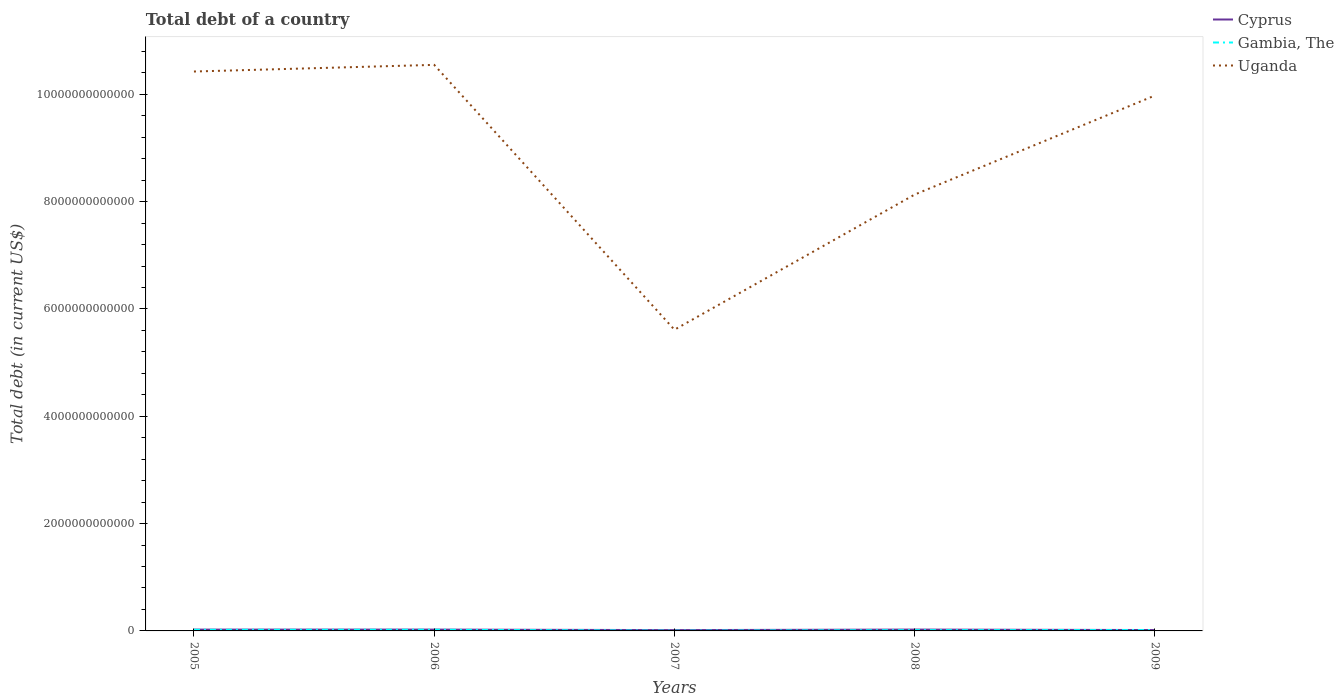Does the line corresponding to Cyprus intersect with the line corresponding to Uganda?
Provide a short and direct response. No. Is the number of lines equal to the number of legend labels?
Offer a very short reply. Yes. Across all years, what is the maximum debt in Gambia, The?
Provide a short and direct response. 4.74e+09. What is the total debt in Gambia, The in the graph?
Offer a very short reply. -1.09e+1. What is the difference between the highest and the second highest debt in Gambia, The?
Offer a very short reply. 1.70e+1. What is the difference between the highest and the lowest debt in Cyprus?
Make the answer very short. 3. What is the difference between two consecutive major ticks on the Y-axis?
Offer a terse response. 2.00e+12. Are the values on the major ticks of Y-axis written in scientific E-notation?
Give a very brief answer. No. Does the graph contain any zero values?
Provide a succinct answer. No. Does the graph contain grids?
Your answer should be compact. No. Where does the legend appear in the graph?
Your answer should be very brief. Top right. How are the legend labels stacked?
Your answer should be very brief. Vertical. What is the title of the graph?
Provide a short and direct response. Total debt of a country. What is the label or title of the X-axis?
Offer a terse response. Years. What is the label or title of the Y-axis?
Your answer should be very brief. Total debt (in current US$). What is the Total debt (in current US$) of Cyprus in 2005?
Your response must be concise. 2.43e+1. What is the Total debt (in current US$) in Gambia, The in 2005?
Provide a succinct answer. 2.06e+1. What is the Total debt (in current US$) in Uganda in 2005?
Your response must be concise. 1.04e+13. What is the Total debt (in current US$) in Cyprus in 2006?
Your answer should be very brief. 2.47e+1. What is the Total debt (in current US$) in Gambia, The in 2006?
Give a very brief answer. 2.18e+1. What is the Total debt (in current US$) in Uganda in 2006?
Make the answer very short. 1.05e+13. What is the Total debt (in current US$) in Cyprus in 2007?
Ensure brevity in your answer.  1.54e+1. What is the Total debt (in current US$) in Gambia, The in 2007?
Provide a short and direct response. 4.74e+09. What is the Total debt (in current US$) in Uganda in 2007?
Your answer should be compact. 5.61e+12. What is the Total debt (in current US$) of Cyprus in 2008?
Make the answer very short. 2.49e+1. What is the Total debt (in current US$) of Gambia, The in 2008?
Ensure brevity in your answer.  1.49e+1. What is the Total debt (in current US$) in Uganda in 2008?
Your answer should be compact. 8.13e+12. What is the Total debt (in current US$) of Cyprus in 2009?
Offer a very short reply. 1.65e+1. What is the Total debt (in current US$) of Gambia, The in 2009?
Make the answer very short. 1.56e+1. What is the Total debt (in current US$) in Uganda in 2009?
Your response must be concise. 9.98e+12. Across all years, what is the maximum Total debt (in current US$) of Cyprus?
Offer a very short reply. 2.49e+1. Across all years, what is the maximum Total debt (in current US$) in Gambia, The?
Your answer should be very brief. 2.18e+1. Across all years, what is the maximum Total debt (in current US$) in Uganda?
Provide a short and direct response. 1.05e+13. Across all years, what is the minimum Total debt (in current US$) of Cyprus?
Provide a short and direct response. 1.54e+1. Across all years, what is the minimum Total debt (in current US$) in Gambia, The?
Offer a terse response. 4.74e+09. Across all years, what is the minimum Total debt (in current US$) of Uganda?
Provide a short and direct response. 5.61e+12. What is the total Total debt (in current US$) of Cyprus in the graph?
Your answer should be very brief. 1.06e+11. What is the total Total debt (in current US$) in Gambia, The in the graph?
Offer a very short reply. 7.76e+1. What is the total Total debt (in current US$) in Uganda in the graph?
Your answer should be compact. 4.47e+13. What is the difference between the Total debt (in current US$) in Cyprus in 2005 and that in 2006?
Your response must be concise. -4.30e+08. What is the difference between the Total debt (in current US$) in Gambia, The in 2005 and that in 2006?
Provide a succinct answer. -1.20e+09. What is the difference between the Total debt (in current US$) in Uganda in 2005 and that in 2006?
Keep it short and to the point. -1.24e+11. What is the difference between the Total debt (in current US$) of Cyprus in 2005 and that in 2007?
Make the answer very short. 8.95e+09. What is the difference between the Total debt (in current US$) of Gambia, The in 2005 and that in 2007?
Provide a short and direct response. 1.58e+1. What is the difference between the Total debt (in current US$) of Uganda in 2005 and that in 2007?
Your answer should be compact. 4.81e+12. What is the difference between the Total debt (in current US$) of Cyprus in 2005 and that in 2008?
Keep it short and to the point. -6.18e+08. What is the difference between the Total debt (in current US$) in Gambia, The in 2005 and that in 2008?
Offer a very short reply. 5.69e+09. What is the difference between the Total debt (in current US$) in Uganda in 2005 and that in 2008?
Your response must be concise. 2.29e+12. What is the difference between the Total debt (in current US$) of Cyprus in 2005 and that in 2009?
Provide a short and direct response. 7.77e+09. What is the difference between the Total debt (in current US$) in Gambia, The in 2005 and that in 2009?
Your answer should be compact. 4.96e+09. What is the difference between the Total debt (in current US$) in Uganda in 2005 and that in 2009?
Provide a short and direct response. 4.47e+11. What is the difference between the Total debt (in current US$) of Cyprus in 2006 and that in 2007?
Give a very brief answer. 9.38e+09. What is the difference between the Total debt (in current US$) in Gambia, The in 2006 and that in 2007?
Your response must be concise. 1.70e+1. What is the difference between the Total debt (in current US$) in Uganda in 2006 and that in 2007?
Make the answer very short. 4.94e+12. What is the difference between the Total debt (in current US$) in Cyprus in 2006 and that in 2008?
Your answer should be very brief. -1.88e+08. What is the difference between the Total debt (in current US$) in Gambia, The in 2006 and that in 2008?
Make the answer very short. 6.89e+09. What is the difference between the Total debt (in current US$) of Uganda in 2006 and that in 2008?
Your answer should be very brief. 2.42e+12. What is the difference between the Total debt (in current US$) in Cyprus in 2006 and that in 2009?
Offer a very short reply. 8.20e+09. What is the difference between the Total debt (in current US$) of Gambia, The in 2006 and that in 2009?
Provide a short and direct response. 6.16e+09. What is the difference between the Total debt (in current US$) of Uganda in 2006 and that in 2009?
Your response must be concise. 5.71e+11. What is the difference between the Total debt (in current US$) of Cyprus in 2007 and that in 2008?
Keep it short and to the point. -9.57e+09. What is the difference between the Total debt (in current US$) in Gambia, The in 2007 and that in 2008?
Offer a terse response. -1.01e+1. What is the difference between the Total debt (in current US$) of Uganda in 2007 and that in 2008?
Your response must be concise. -2.52e+12. What is the difference between the Total debt (in current US$) of Cyprus in 2007 and that in 2009?
Provide a short and direct response. -1.17e+09. What is the difference between the Total debt (in current US$) of Gambia, The in 2007 and that in 2009?
Keep it short and to the point. -1.09e+1. What is the difference between the Total debt (in current US$) of Uganda in 2007 and that in 2009?
Offer a very short reply. -4.36e+12. What is the difference between the Total debt (in current US$) in Cyprus in 2008 and that in 2009?
Make the answer very short. 8.39e+09. What is the difference between the Total debt (in current US$) of Gambia, The in 2008 and that in 2009?
Give a very brief answer. -7.27e+08. What is the difference between the Total debt (in current US$) in Uganda in 2008 and that in 2009?
Your answer should be compact. -1.85e+12. What is the difference between the Total debt (in current US$) of Cyprus in 2005 and the Total debt (in current US$) of Gambia, The in 2006?
Ensure brevity in your answer.  2.54e+09. What is the difference between the Total debt (in current US$) of Cyprus in 2005 and the Total debt (in current US$) of Uganda in 2006?
Ensure brevity in your answer.  -1.05e+13. What is the difference between the Total debt (in current US$) of Gambia, The in 2005 and the Total debt (in current US$) of Uganda in 2006?
Ensure brevity in your answer.  -1.05e+13. What is the difference between the Total debt (in current US$) of Cyprus in 2005 and the Total debt (in current US$) of Gambia, The in 2007?
Offer a terse response. 1.96e+1. What is the difference between the Total debt (in current US$) of Cyprus in 2005 and the Total debt (in current US$) of Uganda in 2007?
Make the answer very short. -5.59e+12. What is the difference between the Total debt (in current US$) of Gambia, The in 2005 and the Total debt (in current US$) of Uganda in 2007?
Your response must be concise. -5.59e+12. What is the difference between the Total debt (in current US$) in Cyprus in 2005 and the Total debt (in current US$) in Gambia, The in 2008?
Make the answer very short. 9.42e+09. What is the difference between the Total debt (in current US$) in Cyprus in 2005 and the Total debt (in current US$) in Uganda in 2008?
Make the answer very short. -8.11e+12. What is the difference between the Total debt (in current US$) in Gambia, The in 2005 and the Total debt (in current US$) in Uganda in 2008?
Provide a short and direct response. -8.11e+12. What is the difference between the Total debt (in current US$) in Cyprus in 2005 and the Total debt (in current US$) in Gambia, The in 2009?
Make the answer very short. 8.70e+09. What is the difference between the Total debt (in current US$) of Cyprus in 2005 and the Total debt (in current US$) of Uganda in 2009?
Keep it short and to the point. -9.95e+12. What is the difference between the Total debt (in current US$) in Gambia, The in 2005 and the Total debt (in current US$) in Uganda in 2009?
Make the answer very short. -9.96e+12. What is the difference between the Total debt (in current US$) of Cyprus in 2006 and the Total debt (in current US$) of Gambia, The in 2007?
Offer a terse response. 2.00e+1. What is the difference between the Total debt (in current US$) of Cyprus in 2006 and the Total debt (in current US$) of Uganda in 2007?
Offer a terse response. -5.59e+12. What is the difference between the Total debt (in current US$) in Gambia, The in 2006 and the Total debt (in current US$) in Uganda in 2007?
Give a very brief answer. -5.59e+12. What is the difference between the Total debt (in current US$) in Cyprus in 2006 and the Total debt (in current US$) in Gambia, The in 2008?
Offer a very short reply. 9.85e+09. What is the difference between the Total debt (in current US$) of Cyprus in 2006 and the Total debt (in current US$) of Uganda in 2008?
Your answer should be very brief. -8.11e+12. What is the difference between the Total debt (in current US$) of Gambia, The in 2006 and the Total debt (in current US$) of Uganda in 2008?
Your response must be concise. -8.11e+12. What is the difference between the Total debt (in current US$) of Cyprus in 2006 and the Total debt (in current US$) of Gambia, The in 2009?
Offer a very short reply. 9.13e+09. What is the difference between the Total debt (in current US$) in Cyprus in 2006 and the Total debt (in current US$) in Uganda in 2009?
Your response must be concise. -9.95e+12. What is the difference between the Total debt (in current US$) of Gambia, The in 2006 and the Total debt (in current US$) of Uganda in 2009?
Provide a succinct answer. -9.96e+12. What is the difference between the Total debt (in current US$) of Cyprus in 2007 and the Total debt (in current US$) of Gambia, The in 2008?
Provide a short and direct response. 4.76e+08. What is the difference between the Total debt (in current US$) of Cyprus in 2007 and the Total debt (in current US$) of Uganda in 2008?
Give a very brief answer. -8.12e+12. What is the difference between the Total debt (in current US$) of Gambia, The in 2007 and the Total debt (in current US$) of Uganda in 2008?
Offer a very short reply. -8.13e+12. What is the difference between the Total debt (in current US$) in Cyprus in 2007 and the Total debt (in current US$) in Gambia, The in 2009?
Offer a very short reply. -2.51e+08. What is the difference between the Total debt (in current US$) in Cyprus in 2007 and the Total debt (in current US$) in Uganda in 2009?
Your answer should be very brief. -9.96e+12. What is the difference between the Total debt (in current US$) of Gambia, The in 2007 and the Total debt (in current US$) of Uganda in 2009?
Provide a short and direct response. -9.97e+12. What is the difference between the Total debt (in current US$) in Cyprus in 2008 and the Total debt (in current US$) in Gambia, The in 2009?
Your answer should be very brief. 9.32e+09. What is the difference between the Total debt (in current US$) in Cyprus in 2008 and the Total debt (in current US$) in Uganda in 2009?
Provide a short and direct response. -9.95e+12. What is the difference between the Total debt (in current US$) in Gambia, The in 2008 and the Total debt (in current US$) in Uganda in 2009?
Offer a terse response. -9.96e+12. What is the average Total debt (in current US$) in Cyprus per year?
Give a very brief answer. 2.12e+1. What is the average Total debt (in current US$) of Gambia, The per year?
Provide a short and direct response. 1.55e+1. What is the average Total debt (in current US$) of Uganda per year?
Offer a terse response. 8.94e+12. In the year 2005, what is the difference between the Total debt (in current US$) of Cyprus and Total debt (in current US$) of Gambia, The?
Your answer should be compact. 3.74e+09. In the year 2005, what is the difference between the Total debt (in current US$) of Cyprus and Total debt (in current US$) of Uganda?
Give a very brief answer. -1.04e+13. In the year 2005, what is the difference between the Total debt (in current US$) in Gambia, The and Total debt (in current US$) in Uganda?
Your response must be concise. -1.04e+13. In the year 2006, what is the difference between the Total debt (in current US$) of Cyprus and Total debt (in current US$) of Gambia, The?
Provide a succinct answer. 2.97e+09. In the year 2006, what is the difference between the Total debt (in current US$) of Cyprus and Total debt (in current US$) of Uganda?
Keep it short and to the point. -1.05e+13. In the year 2006, what is the difference between the Total debt (in current US$) in Gambia, The and Total debt (in current US$) in Uganda?
Provide a succinct answer. -1.05e+13. In the year 2007, what is the difference between the Total debt (in current US$) of Cyprus and Total debt (in current US$) of Gambia, The?
Your answer should be very brief. 1.06e+1. In the year 2007, what is the difference between the Total debt (in current US$) in Cyprus and Total debt (in current US$) in Uganda?
Ensure brevity in your answer.  -5.60e+12. In the year 2007, what is the difference between the Total debt (in current US$) of Gambia, The and Total debt (in current US$) of Uganda?
Provide a succinct answer. -5.61e+12. In the year 2008, what is the difference between the Total debt (in current US$) of Cyprus and Total debt (in current US$) of Gambia, The?
Offer a very short reply. 1.00e+1. In the year 2008, what is the difference between the Total debt (in current US$) of Cyprus and Total debt (in current US$) of Uganda?
Your answer should be compact. -8.11e+12. In the year 2008, what is the difference between the Total debt (in current US$) of Gambia, The and Total debt (in current US$) of Uganda?
Your answer should be very brief. -8.12e+12. In the year 2009, what is the difference between the Total debt (in current US$) of Cyprus and Total debt (in current US$) of Gambia, The?
Your response must be concise. 9.22e+08. In the year 2009, what is the difference between the Total debt (in current US$) in Cyprus and Total debt (in current US$) in Uganda?
Your response must be concise. -9.96e+12. In the year 2009, what is the difference between the Total debt (in current US$) in Gambia, The and Total debt (in current US$) in Uganda?
Your response must be concise. -9.96e+12. What is the ratio of the Total debt (in current US$) in Cyprus in 2005 to that in 2006?
Keep it short and to the point. 0.98. What is the ratio of the Total debt (in current US$) of Gambia, The in 2005 to that in 2006?
Your answer should be very brief. 0.94. What is the ratio of the Total debt (in current US$) of Uganda in 2005 to that in 2006?
Ensure brevity in your answer.  0.99. What is the ratio of the Total debt (in current US$) of Cyprus in 2005 to that in 2007?
Your answer should be compact. 1.58. What is the ratio of the Total debt (in current US$) of Gambia, The in 2005 to that in 2007?
Offer a very short reply. 4.34. What is the ratio of the Total debt (in current US$) of Uganda in 2005 to that in 2007?
Make the answer very short. 1.86. What is the ratio of the Total debt (in current US$) of Cyprus in 2005 to that in 2008?
Ensure brevity in your answer.  0.98. What is the ratio of the Total debt (in current US$) of Gambia, The in 2005 to that in 2008?
Provide a succinct answer. 1.38. What is the ratio of the Total debt (in current US$) in Uganda in 2005 to that in 2008?
Make the answer very short. 1.28. What is the ratio of the Total debt (in current US$) of Cyprus in 2005 to that in 2009?
Your response must be concise. 1.47. What is the ratio of the Total debt (in current US$) in Gambia, The in 2005 to that in 2009?
Your answer should be very brief. 1.32. What is the ratio of the Total debt (in current US$) of Uganda in 2005 to that in 2009?
Your answer should be very brief. 1.04. What is the ratio of the Total debt (in current US$) of Cyprus in 2006 to that in 2007?
Your response must be concise. 1.61. What is the ratio of the Total debt (in current US$) in Gambia, The in 2006 to that in 2007?
Ensure brevity in your answer.  4.59. What is the ratio of the Total debt (in current US$) of Uganda in 2006 to that in 2007?
Make the answer very short. 1.88. What is the ratio of the Total debt (in current US$) of Gambia, The in 2006 to that in 2008?
Your response must be concise. 1.46. What is the ratio of the Total debt (in current US$) of Uganda in 2006 to that in 2008?
Your answer should be very brief. 1.3. What is the ratio of the Total debt (in current US$) of Cyprus in 2006 to that in 2009?
Keep it short and to the point. 1.5. What is the ratio of the Total debt (in current US$) of Gambia, The in 2006 to that in 2009?
Offer a terse response. 1.39. What is the ratio of the Total debt (in current US$) in Uganda in 2006 to that in 2009?
Your answer should be compact. 1.06. What is the ratio of the Total debt (in current US$) of Cyprus in 2007 to that in 2008?
Provide a succinct answer. 0.62. What is the ratio of the Total debt (in current US$) of Gambia, The in 2007 to that in 2008?
Keep it short and to the point. 0.32. What is the ratio of the Total debt (in current US$) in Uganda in 2007 to that in 2008?
Your answer should be very brief. 0.69. What is the ratio of the Total debt (in current US$) of Cyprus in 2007 to that in 2009?
Offer a very short reply. 0.93. What is the ratio of the Total debt (in current US$) in Gambia, The in 2007 to that in 2009?
Keep it short and to the point. 0.3. What is the ratio of the Total debt (in current US$) of Uganda in 2007 to that in 2009?
Offer a terse response. 0.56. What is the ratio of the Total debt (in current US$) of Cyprus in 2008 to that in 2009?
Your answer should be compact. 1.51. What is the ratio of the Total debt (in current US$) of Gambia, The in 2008 to that in 2009?
Keep it short and to the point. 0.95. What is the ratio of the Total debt (in current US$) of Uganda in 2008 to that in 2009?
Make the answer very short. 0.81. What is the difference between the highest and the second highest Total debt (in current US$) in Cyprus?
Provide a short and direct response. 1.88e+08. What is the difference between the highest and the second highest Total debt (in current US$) of Gambia, The?
Your answer should be compact. 1.20e+09. What is the difference between the highest and the second highest Total debt (in current US$) in Uganda?
Provide a succinct answer. 1.24e+11. What is the difference between the highest and the lowest Total debt (in current US$) of Cyprus?
Make the answer very short. 9.57e+09. What is the difference between the highest and the lowest Total debt (in current US$) of Gambia, The?
Keep it short and to the point. 1.70e+1. What is the difference between the highest and the lowest Total debt (in current US$) in Uganda?
Offer a very short reply. 4.94e+12. 